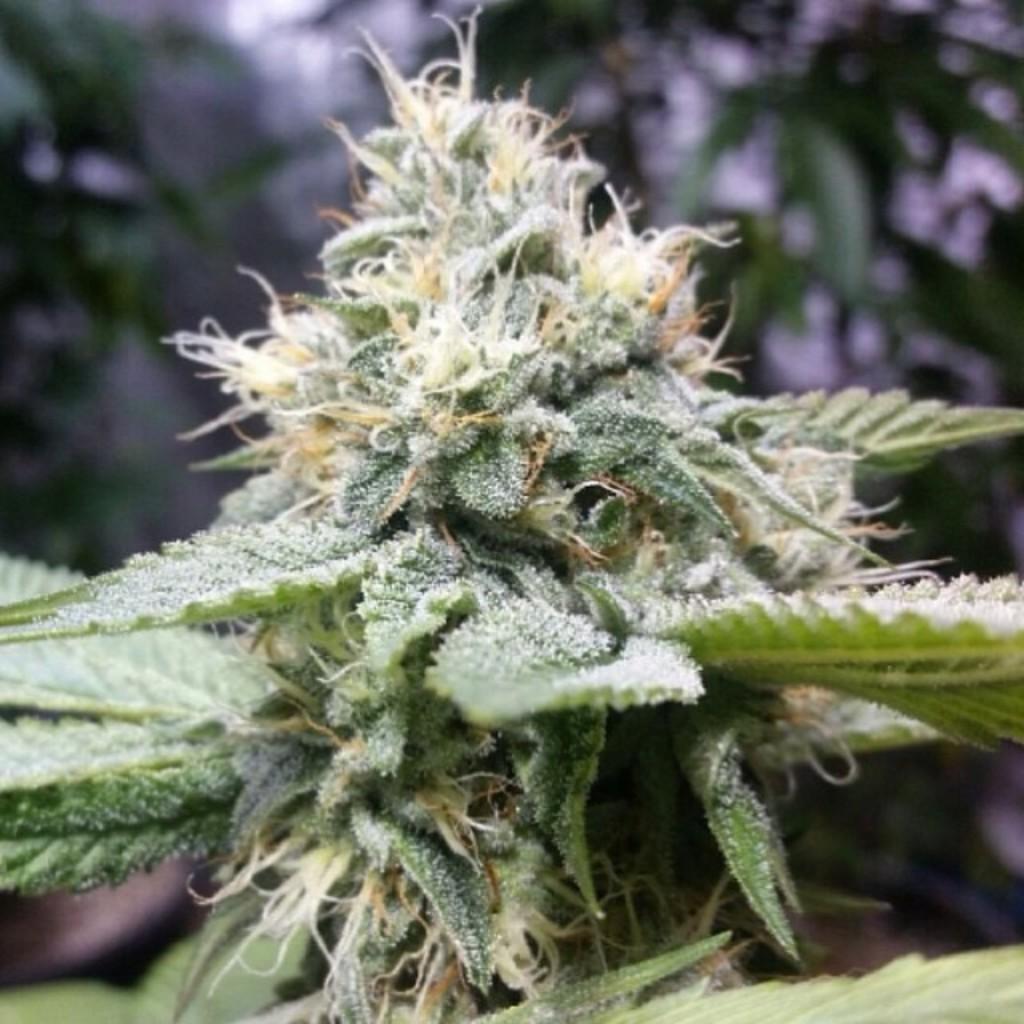In one or two sentences, can you explain what this image depicts? In this image I can see the plant and the plant is in green color, background I can see few trees in green color and the sky is in white color. 